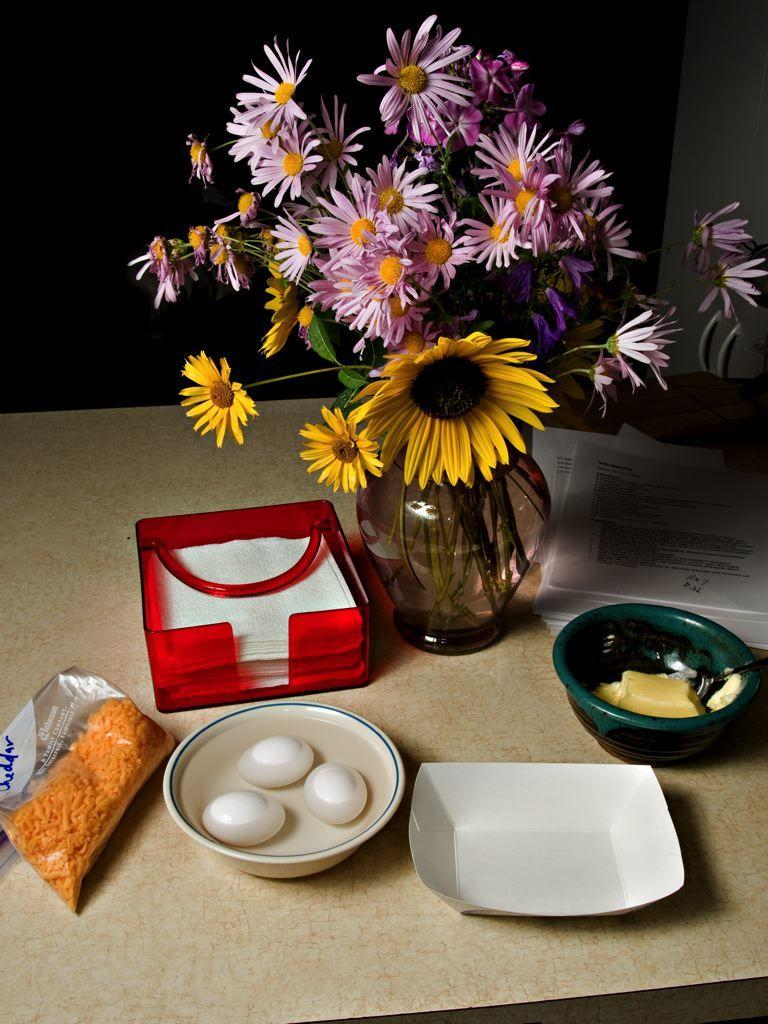What object is present in the image that is typically used for holding plants? There is a flower pot in the image. What items are contained within the bowls in the image? The bowls contain eggs. Where are the bowls located in the image? The bowls are on a table. What object in the image is used for dispensing tissues and has a red color? There is a red-colored tissue box in the image. What type of stocking is being used to hold the eggs in the image? There are no stockings present in the image; the eggs are contained within bowls. 